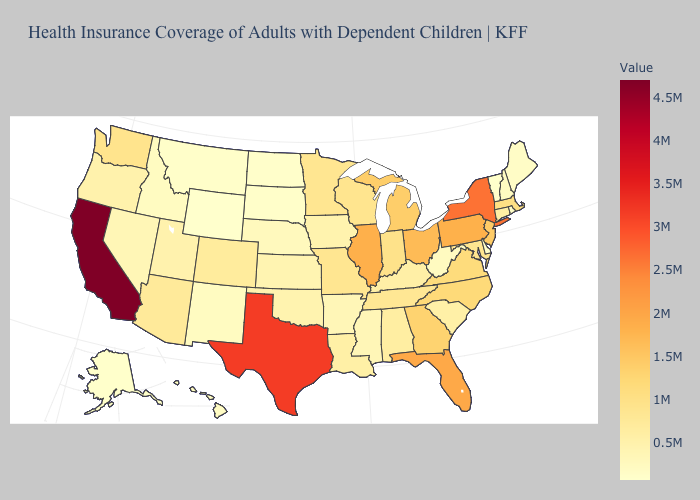Does California have the highest value in the USA?
Short answer required. Yes. Among the states that border Virginia , does North Carolina have the highest value?
Give a very brief answer. Yes. Among the states that border Alabama , does Mississippi have the highest value?
Concise answer only. No. Does Wyoming have the highest value in the West?
Short answer required. No. Which states hav the highest value in the South?
Write a very short answer. Texas. Among the states that border Delaware , does New Jersey have the highest value?
Concise answer only. No. 